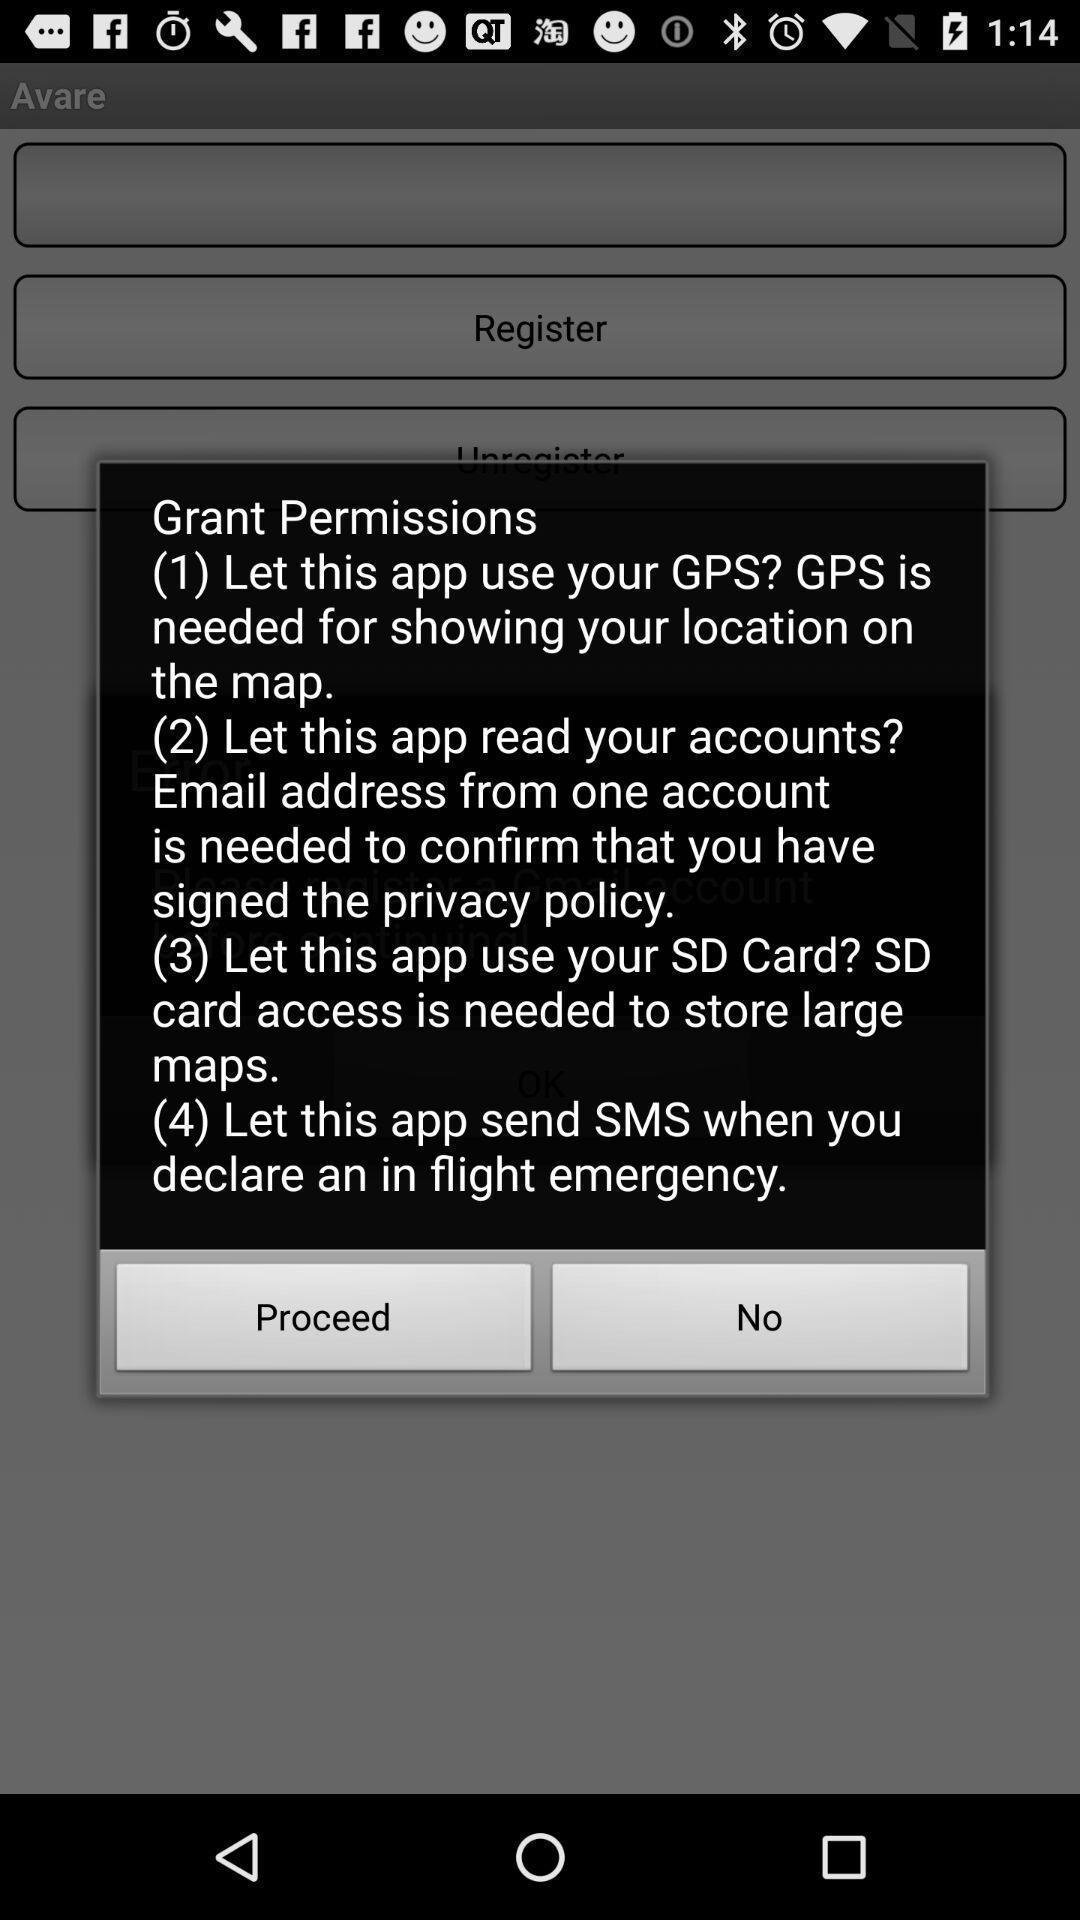Describe the visual elements of this screenshot. Pop-up shows permissions details. 